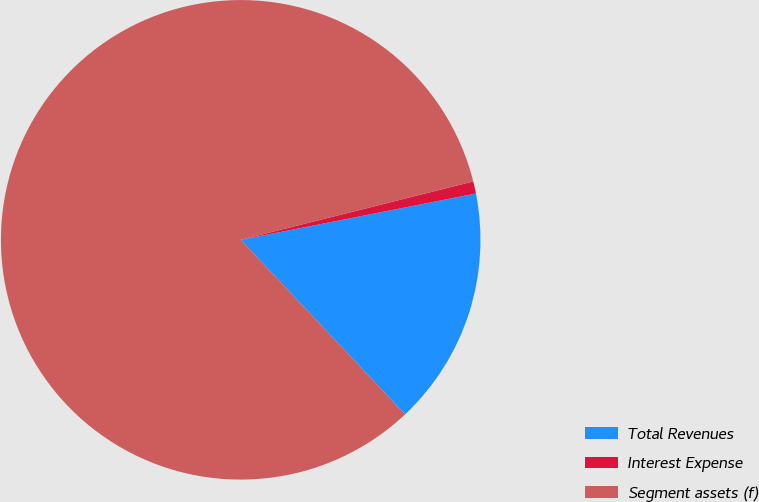Convert chart. <chart><loc_0><loc_0><loc_500><loc_500><pie_chart><fcel>Total Revenues<fcel>Interest Expense<fcel>Segment assets (f)<nl><fcel>16.07%<fcel>0.82%<fcel>83.11%<nl></chart> 